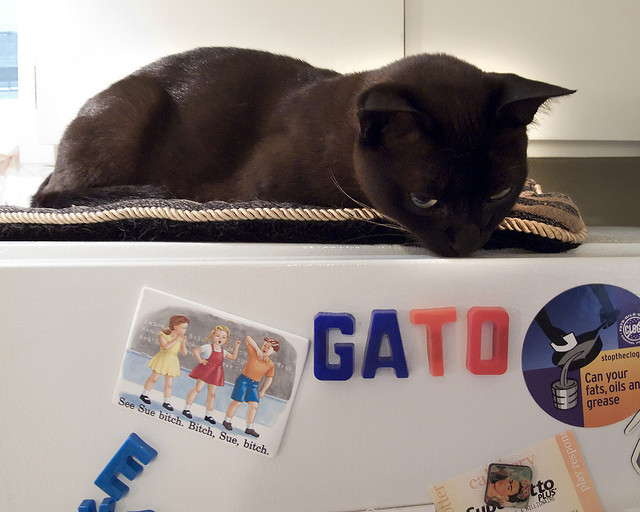Read and extract the text from this image. GATO E See Sue bitch. Bitch. Sue, bitch. PLUS PLUS PLUS grease oils fats your Can 